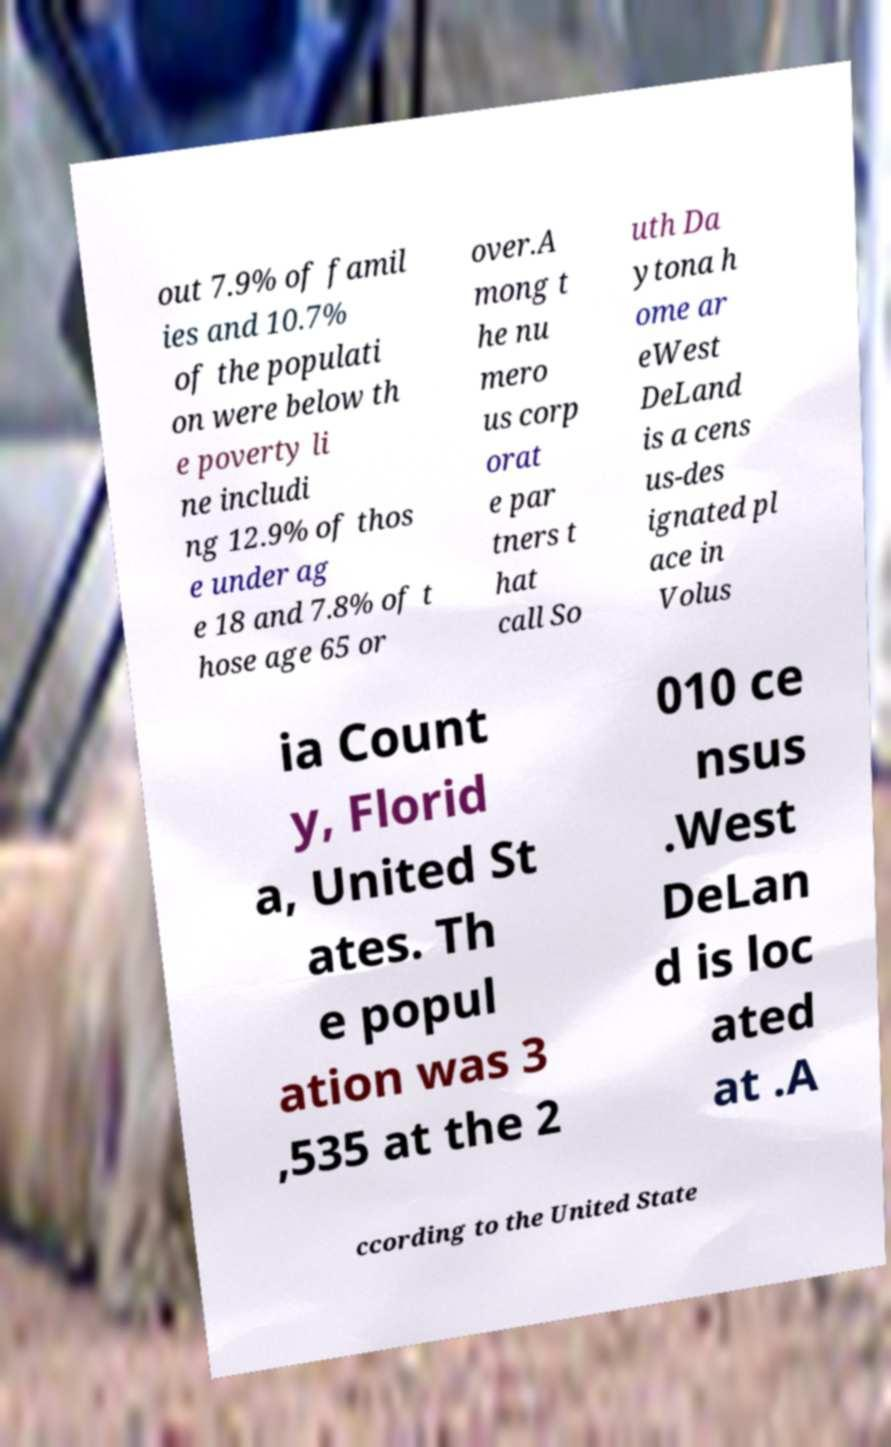What messages or text are displayed in this image? I need them in a readable, typed format. out 7.9% of famil ies and 10.7% of the populati on were below th e poverty li ne includi ng 12.9% of thos e under ag e 18 and 7.8% of t hose age 65 or over.A mong t he nu mero us corp orat e par tners t hat call So uth Da ytona h ome ar eWest DeLand is a cens us-des ignated pl ace in Volus ia Count y, Florid a, United St ates. Th e popul ation was 3 ,535 at the 2 010 ce nsus .West DeLan d is loc ated at .A ccording to the United State 